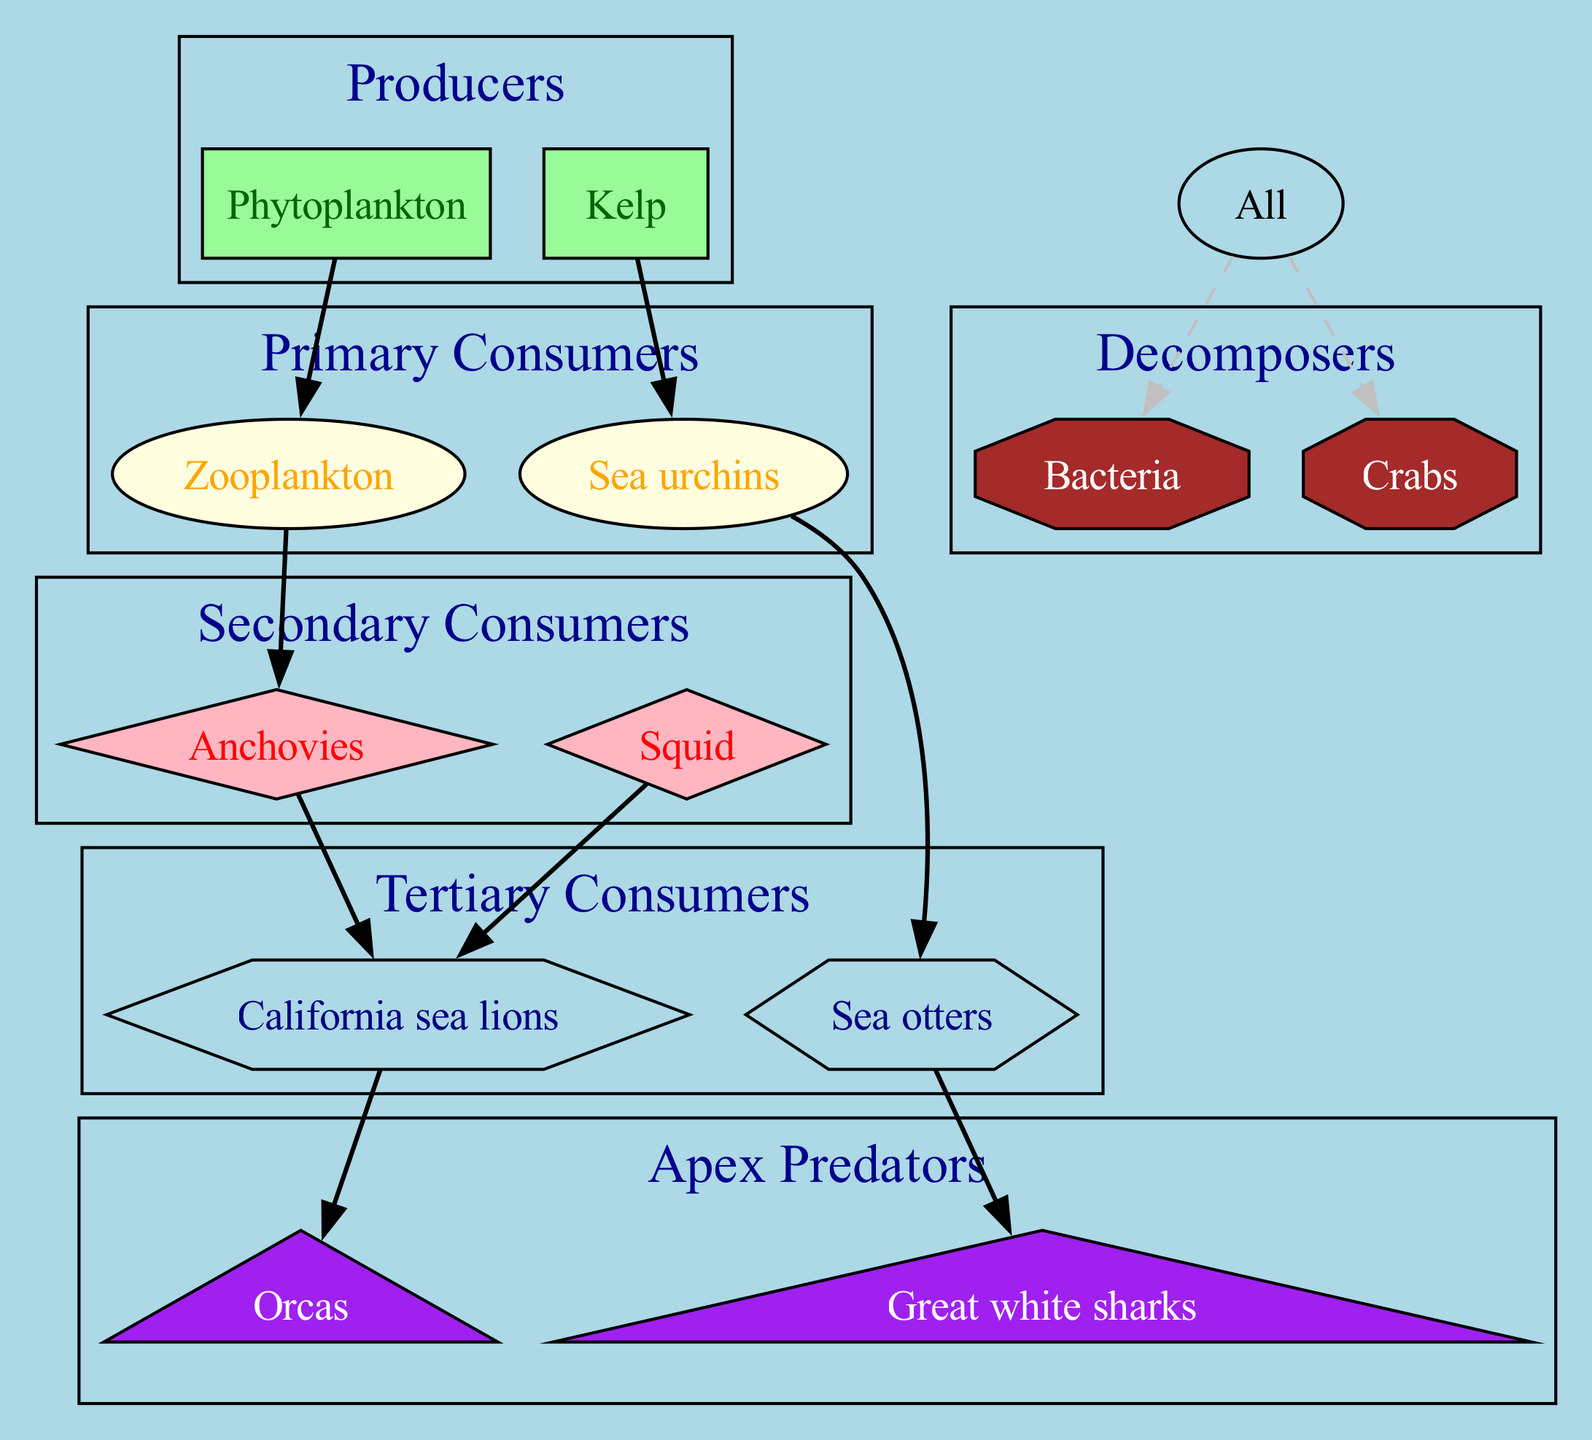What are the producers in the food web? The producers listed in the diagram are Phytoplankton and Kelp. These organisms form the base of the food web and provide energy for the primary consumers above them.
Answer: Phytoplankton, Kelp How many secondary consumers are shown in the diagram? The diagram includes two secondary consumers: Anchovies and Squid. Counting these organisms gives a total of two secondary consumers.
Answer: 2 What do zooplankton feed on? According to the relationships in the diagram, Zooplankton are shown to consume Phytoplankton, which classifies them as primary consumers that rely on producers for energy.
Answer: Phytoplankton Which organism is at the top of the food chain? The apex predators at the top of the food chain in the diagram are Great white sharks and Orcas. They are the final consumers in this food web, indicating they have no natural predators.
Answer: Great white sharks, Orcas What is the relationship between sea otters and great white sharks? Based on the relationships depicted in the diagram, Sea otters are prey for Great white sharks, meaning they are part of a direct feeding relationship where the predator consumes the prey.
Answer: Sea otters -> Great white sharks How many decomposers are mentioned in the food web? The diagram specifies that there are two decomposers: Bacteria and Crabs. These organisms play a crucial role in breaking down organic matter in the ecosystem.
Answer: 2 Who consumes California sea lions? The diagram indicates that Orcas consume California sea lions, highlighting their position as apex predators that can feed on large marine mammals.
Answer: Orcas What is the role of bacteria in the food web? Bacteria are portrayed as decomposers in the food web, meaning their role is to break down organic material from all organisms upon their death, facilitating nutrient recycling in the ecosystem.
Answer: Decomposers What type of consumers are sea urchins categorized as? Sea urchins are categorized as primary consumers in the diagram because they feed on producers like Kelp, thus directly utilizing the energy from primary production.
Answer: Primary consumers 